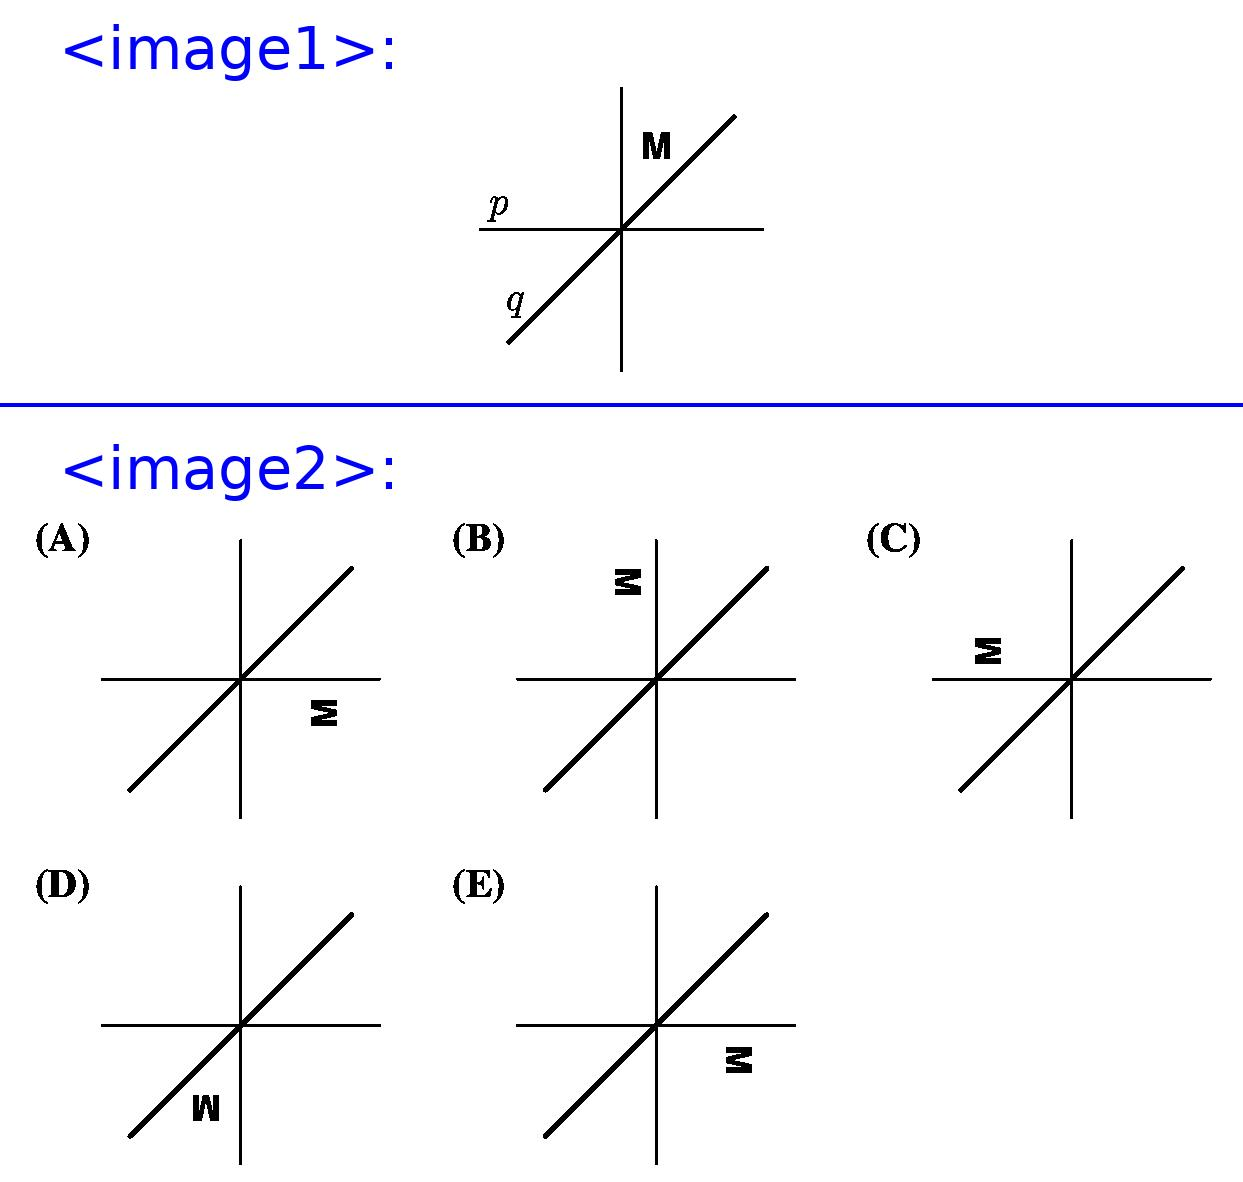Is there a way to predict the final position of an object after multiple reflections without drawing? Yes, while drawing can be a helpful visual aid, you can predict the outcome of multiple reflections analytically by understanding the properties of reflections. If you know the orientation of the lines of reflection and their angles, you can determine the final orientation of the object. For instance, two reflections across two parallel lines will translate the object, whereas reflections across intersecting lines will result in a rotated figure. The number and positions of both axes of symmetry are vital to predict the result of reflections mathematically. 